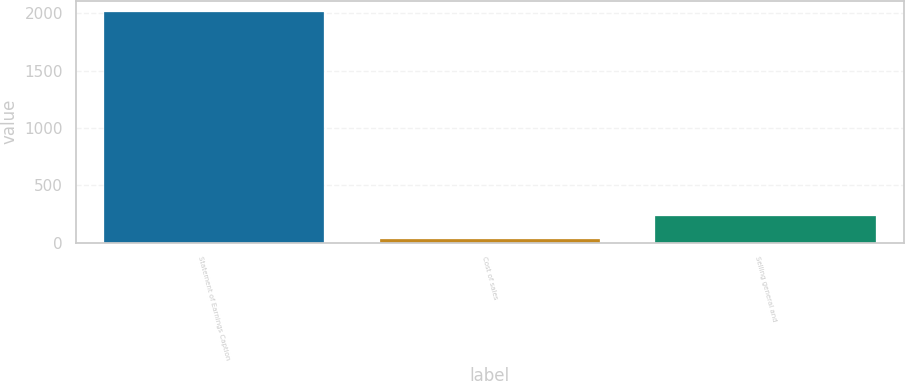Convert chart to OTSL. <chart><loc_0><loc_0><loc_500><loc_500><bar_chart><fcel>Statement of Earnings Caption<fcel>Cost of sales<fcel>Selling general and<nl><fcel>2008<fcel>33.1<fcel>230.59<nl></chart> 